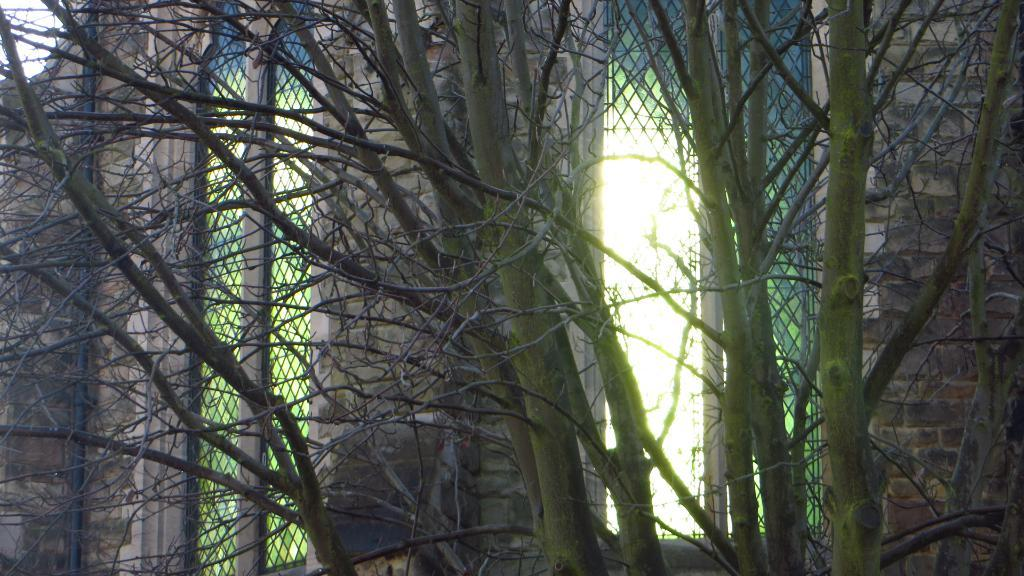What type of natural elements can be seen in the image? There is a group of trees in the image. What type of man-made structure is present in the image? There is a building in the image. What architectural feature can be seen on the building? There are windows visible in the image. What can be seen in the background of the image? The sky is visible in the background of the image. What type of secretary can be seen working in the building in the image? There is no secretary present in the image; it only shows a group of trees, a building, windows, and the sky. Can you see a plane flying in the sky in the image? There is no plane visible in the sky in the image. 